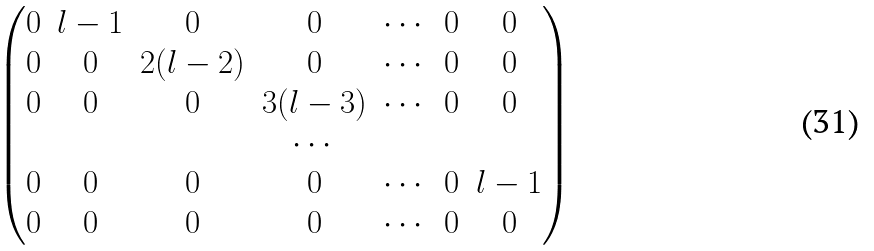Convert formula to latex. <formula><loc_0><loc_0><loc_500><loc_500>\begin{pmatrix} 0 & l - 1 & 0 & 0 & \cdots & 0 & 0 \\ 0 & 0 & 2 ( l - 2 ) & 0 & \cdots & 0 & 0 \\ 0 & 0 & 0 & 3 ( l - 3 ) & \cdots & 0 & 0 \\ & & & \cdots & & \\ 0 & 0 & 0 & 0 & \cdots & 0 & l - 1 \\ 0 & 0 & 0 & 0 & \cdots & 0 & 0 \end{pmatrix}</formula> 